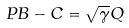<formula> <loc_0><loc_0><loc_500><loc_500>P B - C = \sqrt { \gamma } Q</formula> 